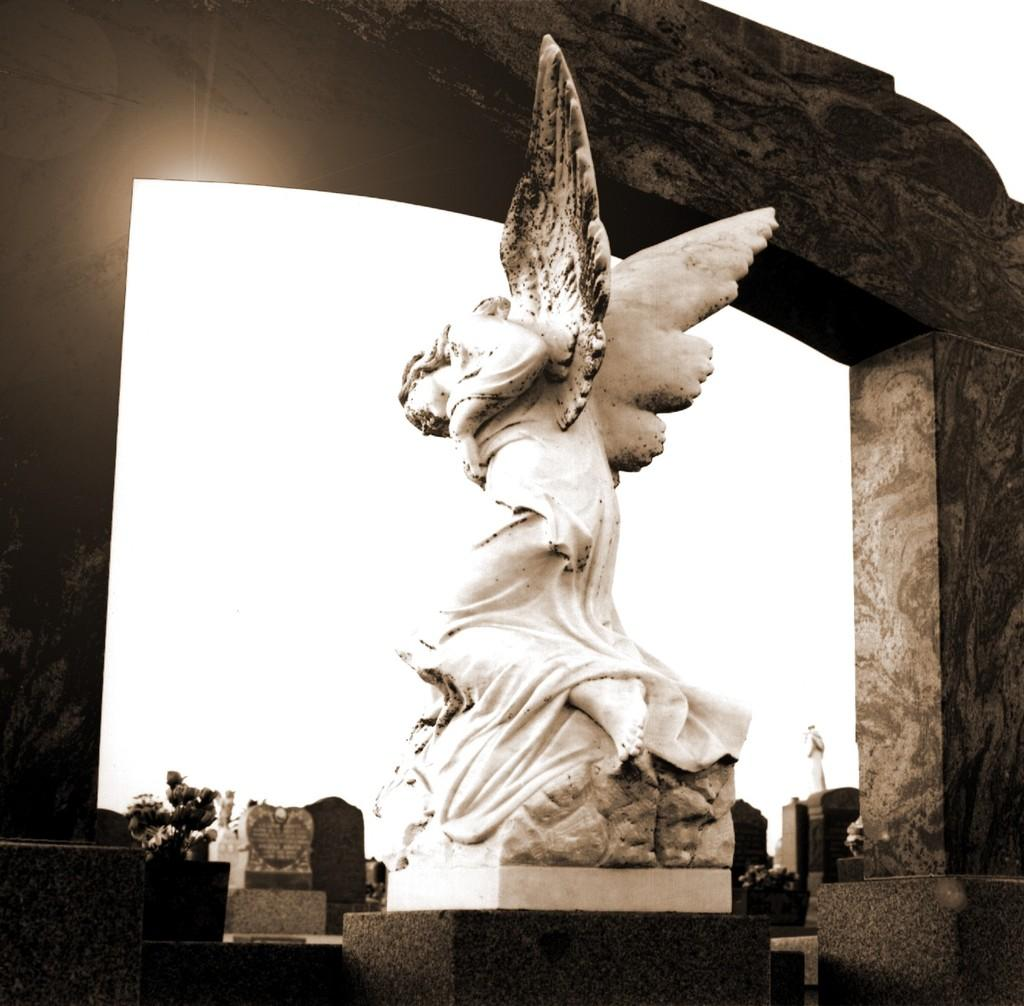What is the main subject in the image? There is a statue in the image. What else can be seen in the image besides the statue? There are buildings in the image. What is visible in the background of the image? The sky is visible in the image. What type of record is being played by the statue in the image? There is no record or any indication of music being played in the image; the statue is the main subject. 